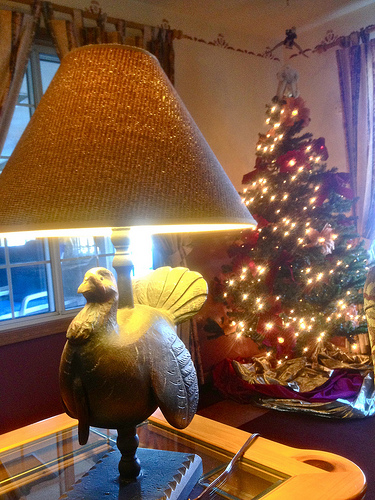<image>
Is the lamp shade on the tree? No. The lamp shade is not positioned on the tree. They may be near each other, but the lamp shade is not supported by or resting on top of the tree. 